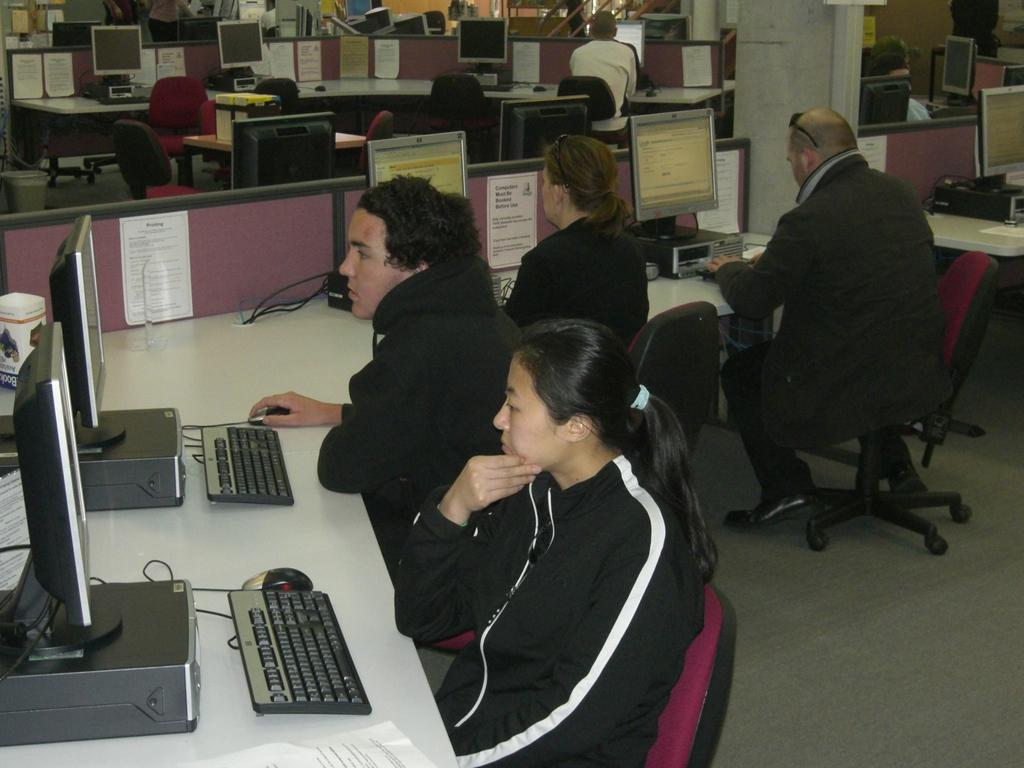What are the people in the image doing? The people in the image are sitting on chairs. What are the people looking at while sitting on the chairs? The people are looking at a computer. Where is the computer located in the image? The computer is on a desk. What type of yak can be seen in the image? There is no yak present in the image; it features people sitting on chairs and looking at a computer. What reward is the achiever receiving in the image? There is no achiever or reward present in the image. 